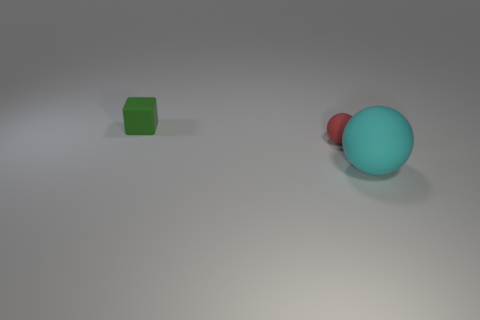Add 2 big cyan matte spheres. How many objects exist? 5 Subtract all balls. How many objects are left? 1 Add 2 purple shiny cubes. How many purple shiny cubes exist? 2 Subtract 0 cyan cylinders. How many objects are left? 3 Subtract all red rubber balls. Subtract all tiny blocks. How many objects are left? 1 Add 1 red matte spheres. How many red matte spheres are left? 2 